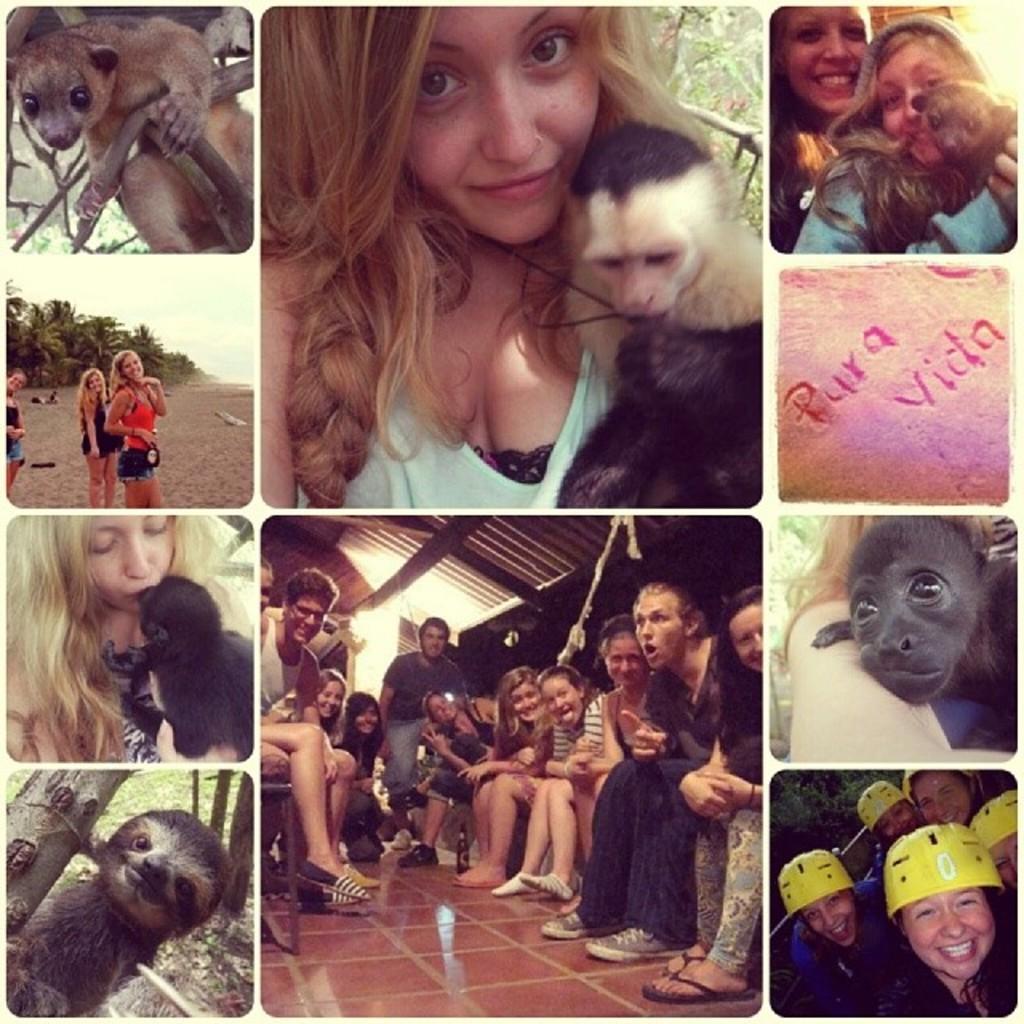Please provide a concise description of this image. This is an edited image. Woman in white t-shirt is holding monkey in her hand. Under the image, we see many people sitting on chair. Beside that, we see an animal which is black in color and below that, we see many people wearing yellow helmet. On the left corner of the picture, we see two animals one on the top and the other on the bottom of this edited picture and in the left corner, women are standing near the beach. On the right corner, we see a text written on it. 